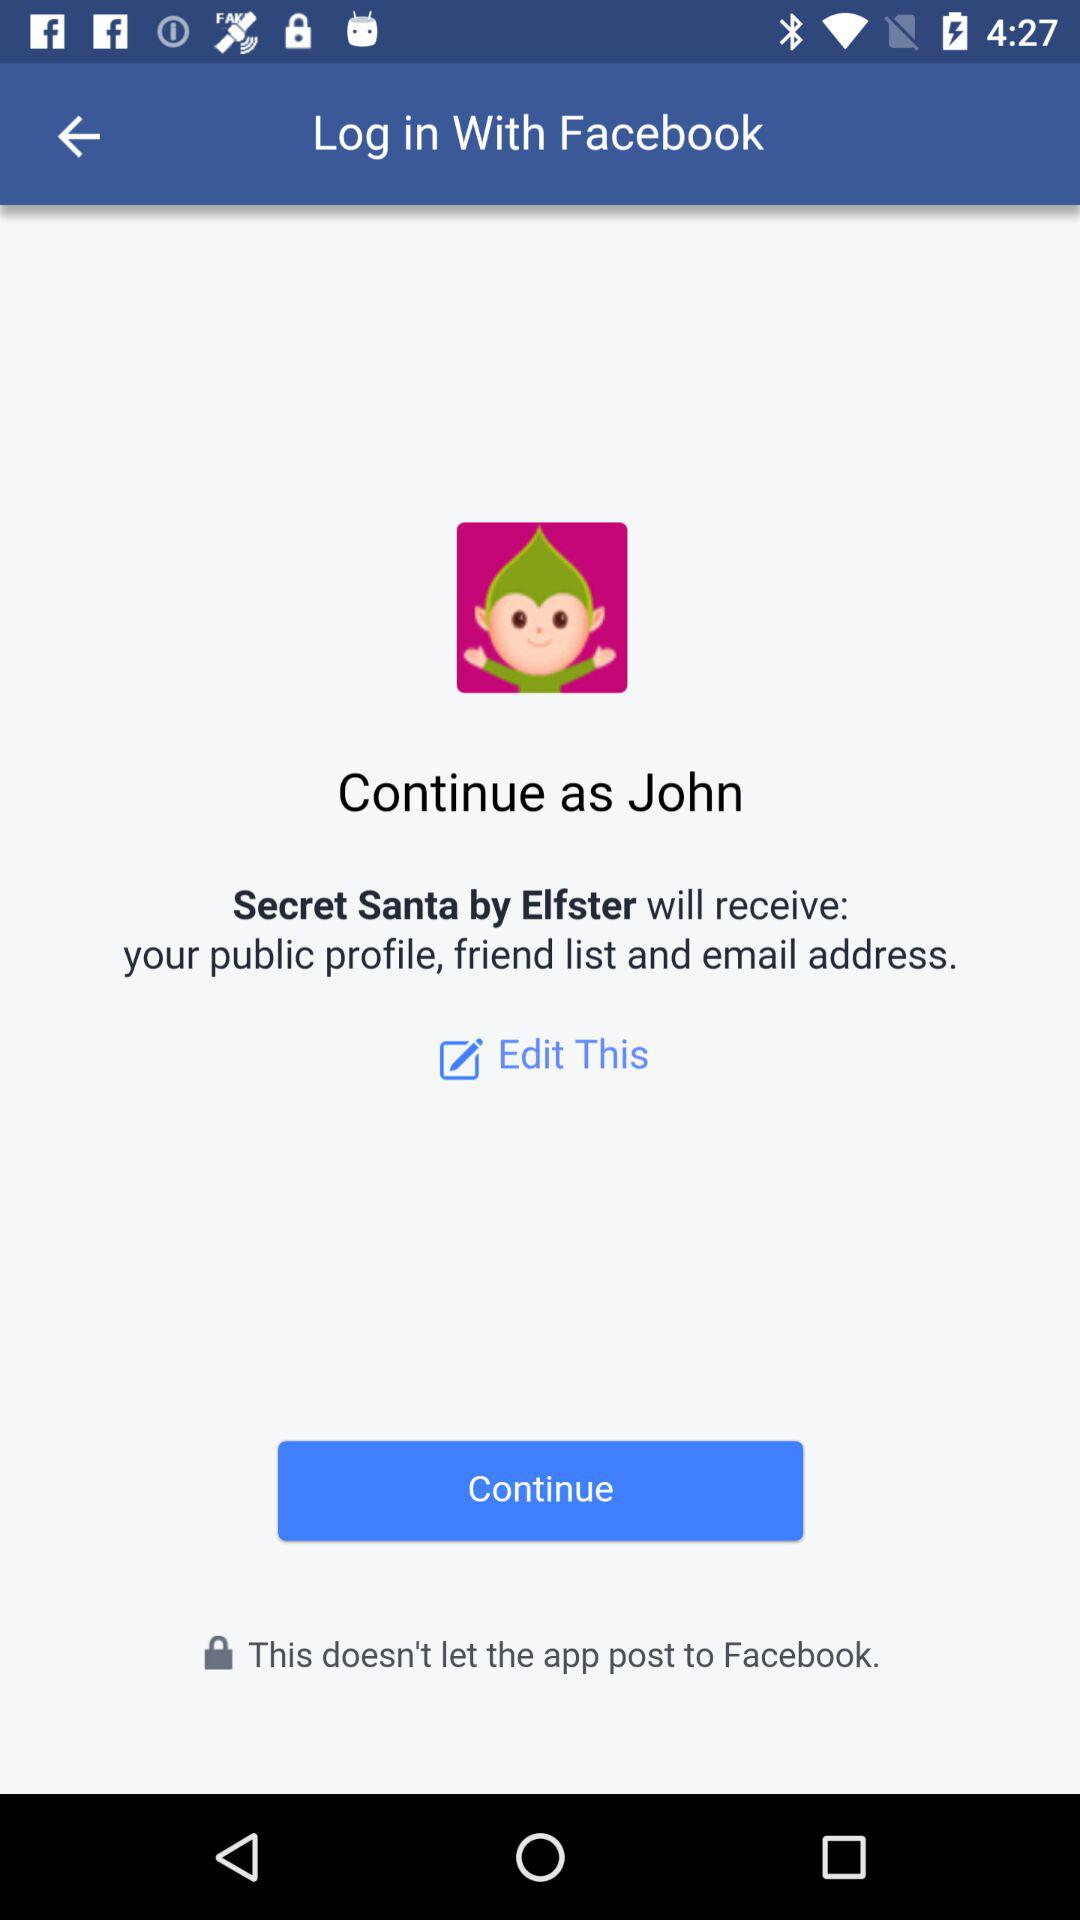By what username can the application be continued? The username is "John". 